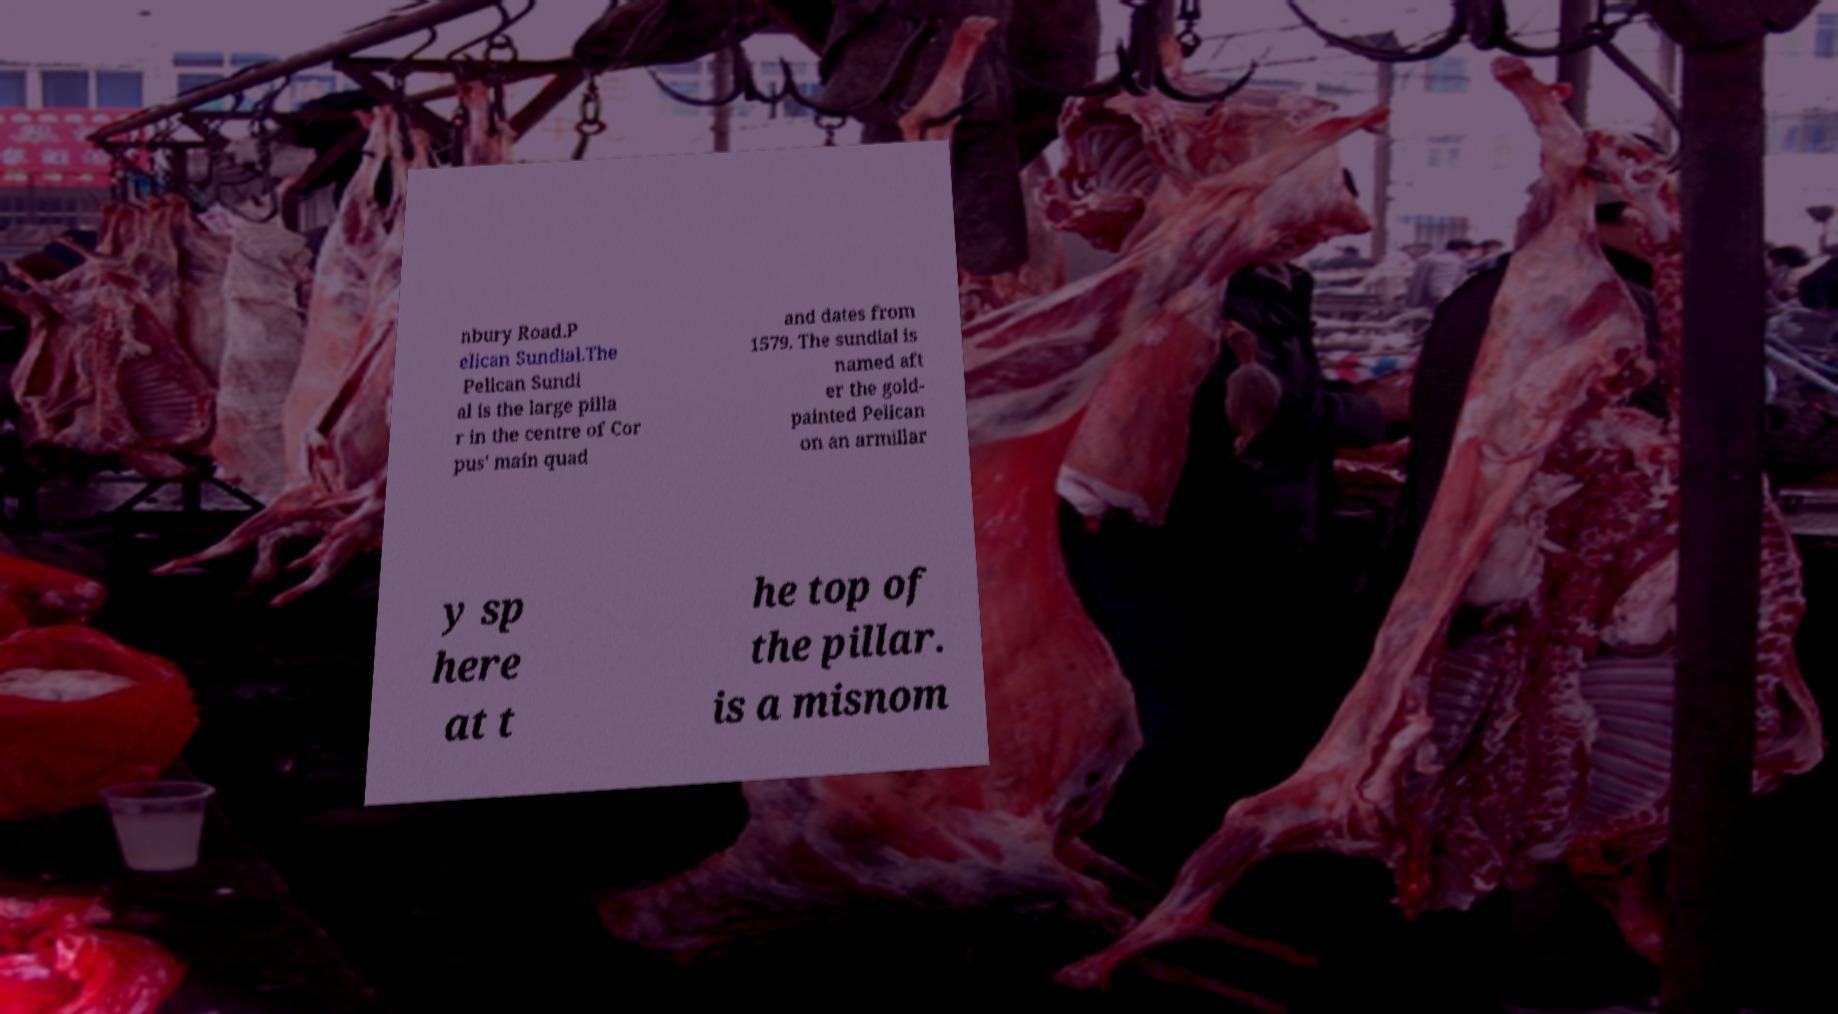There's text embedded in this image that I need extracted. Can you transcribe it verbatim? nbury Road.P elican Sundial.The Pelican Sundi al is the large pilla r in the centre of Cor pus' main quad and dates from 1579. The sundial is named aft er the gold- painted Pelican on an armillar y sp here at t he top of the pillar. is a misnom 